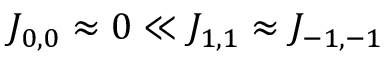Convert formula to latex. <formula><loc_0><loc_0><loc_500><loc_500>J _ { 0 , 0 } \approx 0 \ll J _ { 1 , 1 } \approx J _ { - 1 , - 1 }</formula> 